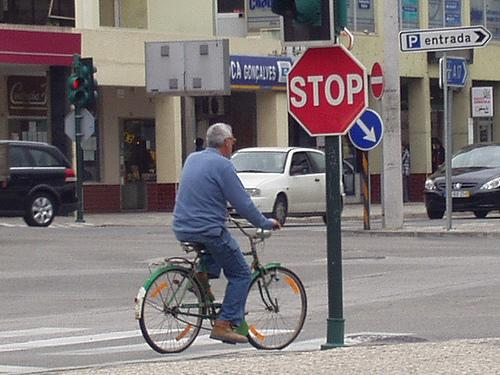Question: where is the man on the bike at in picture?
Choices:
A. Next to stop sign.
B. Sidewalk.
C. By red car.
D. Under blue bus.
Answer with the letter. Answer: A Question: what does the street sign over the man's head say?
Choices:
A. Stop.
B. Yield.
C. Roy st.
D. Pentrada.
Answer with the letter. Answer: D Question: how many people are in photo?
Choices:
A. One.
B. Five.
C. Six.
D. Nine.
Answer with the letter. Answer: A Question: why did the man on the bike stop?
Choices:
A. Traffic.
B. The stop sign.
C. To rest.
D. To drink water.
Answer with the letter. Answer: B Question: what other form of transportation is in the picture?
Choices:
A. Car.
B. Train.
C. Bus.
D. Bike.
Answer with the letter. Answer: A 